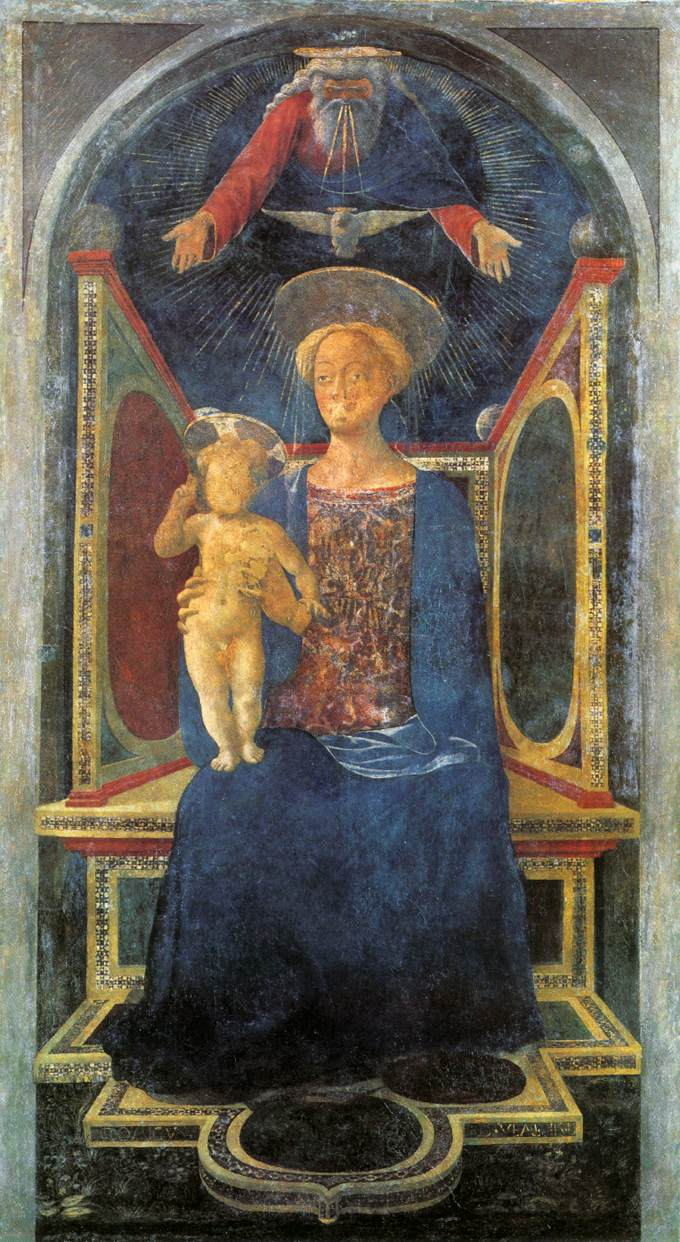What can you tell me about the colors and materials used in creating this artwork? This artwork is a fine example of tempera on wood, a common technique used during the medieval period. The color palette includes rich hues of blue, red, and gold. The blue used for the Virgin Mary's robe signifies purity and divinity. The red and gold signify royalty and holiness. The use of gold, especially in the canopy and the arch, adds a sense of opulence and sacredness to the piece. The tempera technique, which involves mixing pigments with a binder, often egg yolk, results in a vivid and lasting finish. Why might the artist have chosen tempera as the medium for this painting? The artist likely chose tempera as the medium due to its advantages in producing fine, detailed work with long-lasting pigments. During the medieval period, tempera was favored for its fast-drying properties and ability to hold colors vibrantly over time. It allowed artists to achieve smooth and luminous surfaces, ideal for depicting religious themes with an aura of sanctity and reverence. 